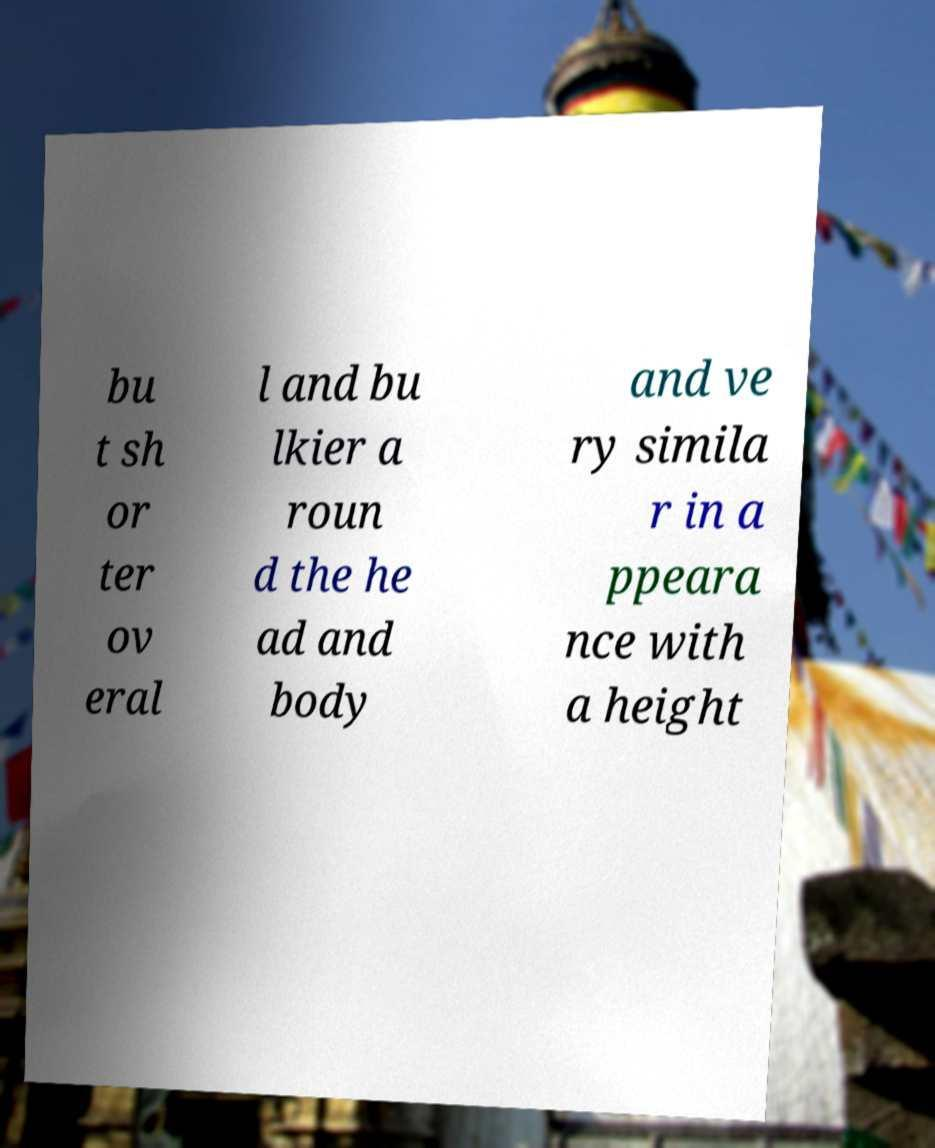What messages or text are displayed in this image? I need them in a readable, typed format. bu t sh or ter ov eral l and bu lkier a roun d the he ad and body and ve ry simila r in a ppeara nce with a height 